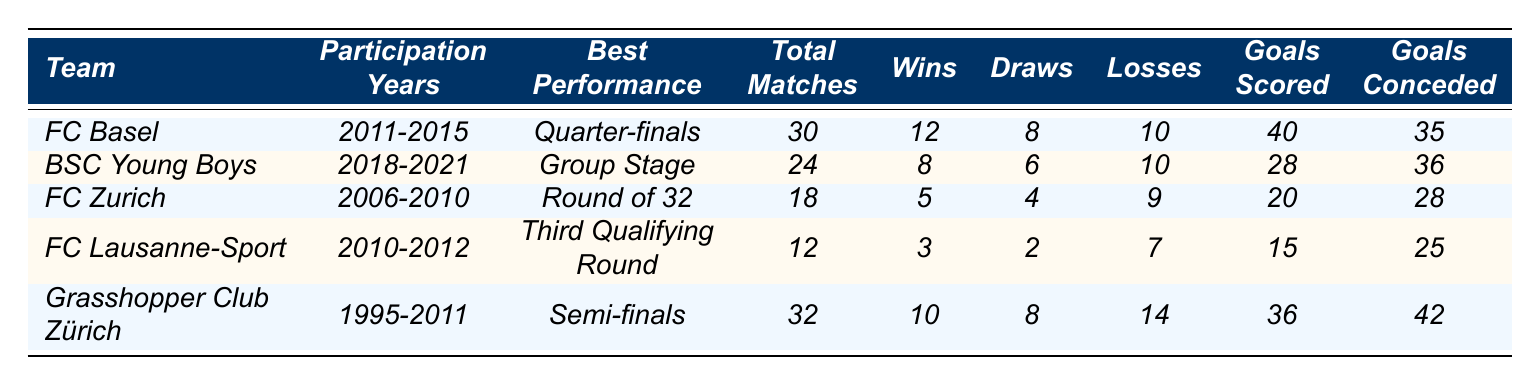What is the best performance achieved by FC Basel in UEFA tournaments? FC Basel's best performance listed in the table is "Quarter-finals".
Answer: Quarter-finals How many total matches did BSC Young Boys play in UEFA tournaments? The table indicates that BSC Young Boys played a total of 24 matches.
Answer: 24 Which Swiss team had the fewest wins in UEFA tournaments? By comparing the number of wins across teams, FC Lausanne-Sport had the fewest wins at 3.
Answer: FC Lausanne-Sport What is the average number of goals scored by FC Zurich per match? FC Zurich scored 20 goals over 18 matches, so the average is 20/18 ≈ 1.11 goals per match.
Answer: Approximately 1.11 How many losses did Grasshopper Club Zürich have across their UEFA tournament participations? The table shows that Grasshopper Club Zürich had 14 losses.
Answer: 14 Was FC Lausanne-Sport's best performance better than FC Zurich's best performance? FC Lausanne-Sport's best was the Third Qualifying Round, while FC Zurich's best was the Round of 32. Since the Round of 32 is a later stage than the Third Qualifying Round, FC Lausanne-Sport’s performance was not better.
Answer: No What is the total number of goals conceded by all Swiss teams listed in the table? Adding the goals conceded: 35 (FC Basel) + 36 (BSC Young Boys) + 28 (FC Zurich) + 25 (FC Lausanne-Sport) + 42 (Grasshopper Club Zürich) gives a total of 166.
Answer: 166 Which team had the highest number of goals scored in UEFA tournaments? By comparing the "Goals Scored" column, FC Basel scored the highest with 40 goals.
Answer: FC Basel How many teams participated in UEFA tournaments between the years 2010 and 2015? The teams participating during those years were FC Basel, FC Lausanne-Sport, and FC Zurich, so three teams participated.
Answer: 3 If you combine the number of wins from FC Basel and Grasshopper Club Zürich, how many wins do they have together? FC Basel has 12 wins and Grasshopper Club Zürich has 10 wins, so combined they have 12 + 10 = 22 wins.
Answer: 22 